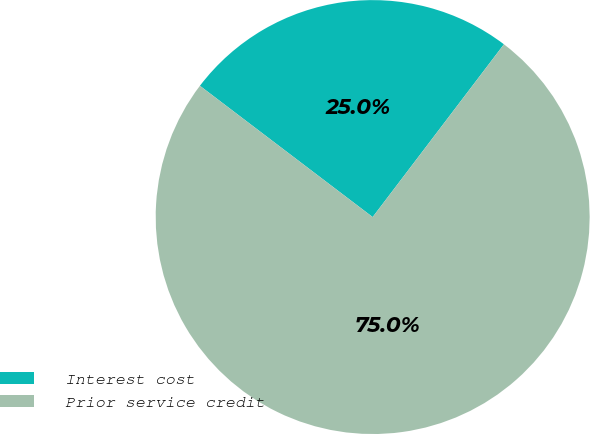Convert chart. <chart><loc_0><loc_0><loc_500><loc_500><pie_chart><fcel>Interest cost<fcel>Prior service credit<nl><fcel>25.0%<fcel>75.0%<nl></chart> 